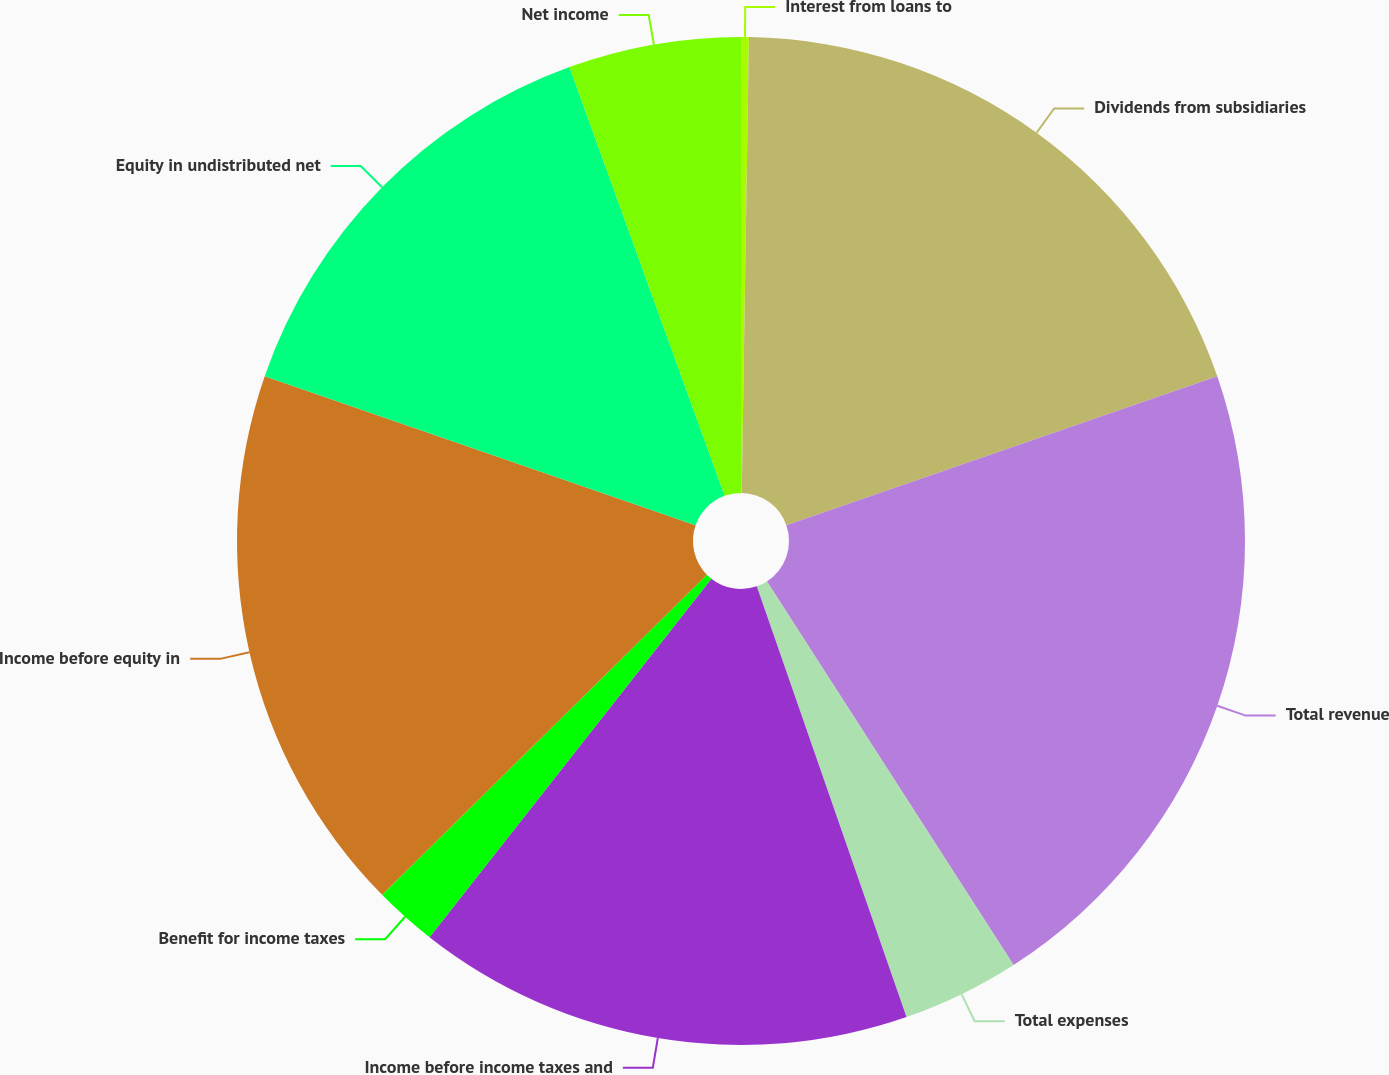Convert chart to OTSL. <chart><loc_0><loc_0><loc_500><loc_500><pie_chart><fcel>Interest from loans to<fcel>Dividends from subsidiaries<fcel>Total revenue<fcel>Total expenses<fcel>Income before income taxes and<fcel>Benefit for income taxes<fcel>Income before equity in<fcel>Equity in undistributed net<fcel>Net income<nl><fcel>0.25%<fcel>19.45%<fcel>21.21%<fcel>3.77%<fcel>15.93%<fcel>2.01%<fcel>17.69%<fcel>14.17%<fcel>5.53%<nl></chart> 